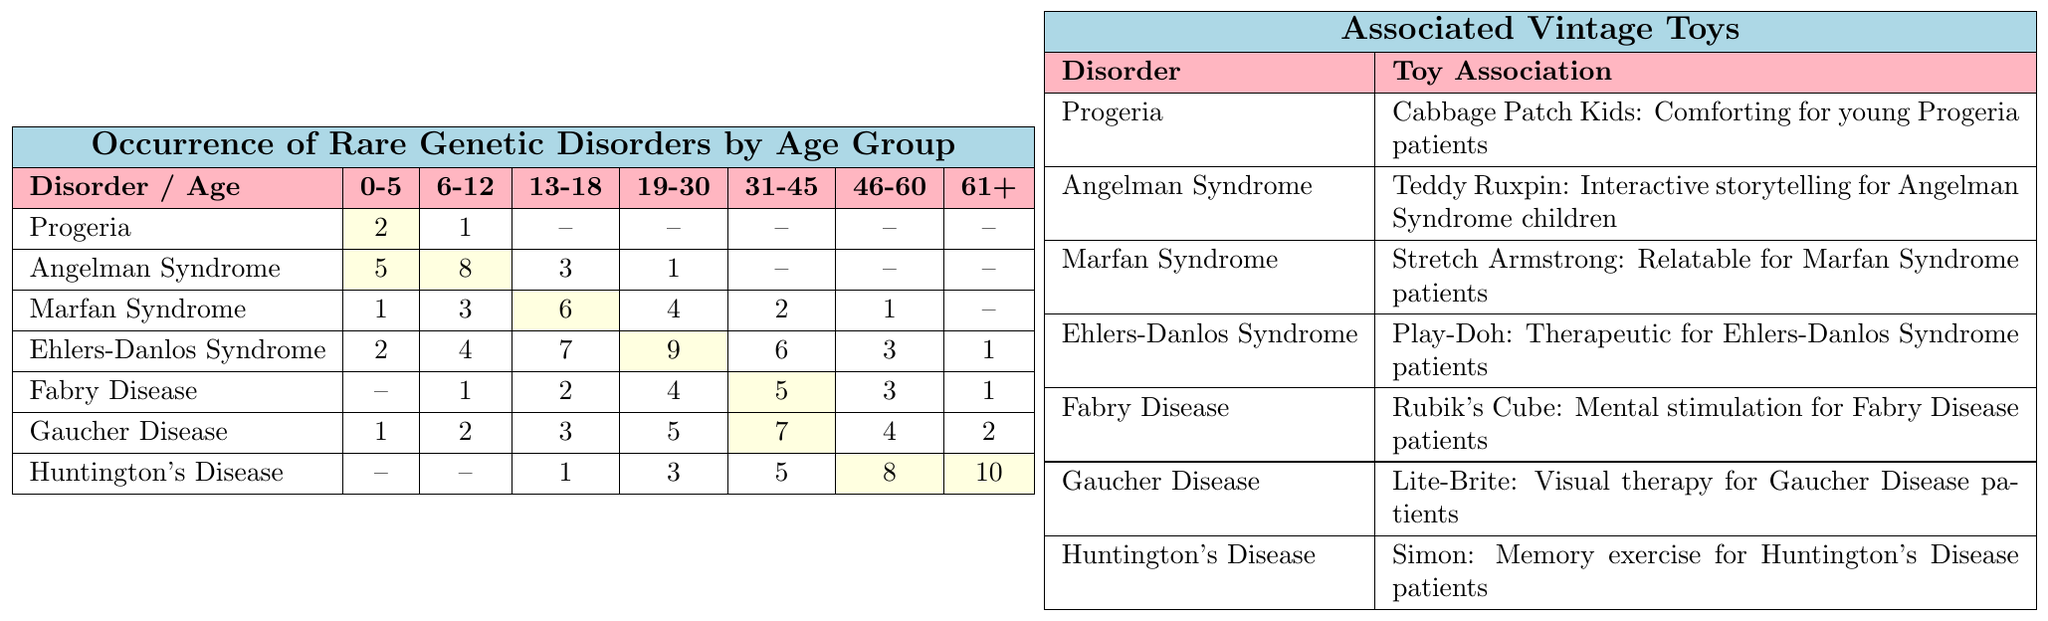What is the occurrence of Progeria in the age group 0-5? According to the table, the occurrence of Progeria in the age group 0-5 is 2.
Answer: 2 Which genetic disorder has the highest occurrence in the age group 19-30? Looking at the table, Ehlers-Danlos Syndrome has the highest occurrence in the age group 19-30 with a value of 9.
Answer: Ehlers-Danlos Syndrome What is the total occurrence of Gaucher Disease across all age groups? To find the total occurrence of Gaucher Disease, we add the values: 1 + 2 + 3 + 5 + 7 + 4 + 2 = 24.
Answer: 24 Does Angelman Syndrome occur in the age group 46-60? The table shows that the occurrence of Angelman Syndrome in the age group 46-60 is 0, which means it does not occur in that age group.
Answer: No Calculate the average occurrence of Huntington's Disease across all age groups. The occurrences for Huntington's Disease are 0, 0, 1, 3, 5, 8, 10. Adding these gives 27, and dividing by the number of age groups (7) gives an average of 27/7 ≈ 3.86.
Answer: Approximately 3.86 Which disorder has a toy association with "visual therapy"? Referring to the toy associations section, Gaucher Disease is associated with Lite-Brite for visual therapy.
Answer: Gaucher Disease Compare the total occurrences of Fabry Disease and Ehlers-Danlos Syndrome in the age group 31-45. Which one has a higher occurrence? The occurrence of Fabry Disease in the age group 31-45 is 5, and the occurrence of Ehlers-Danlos Syndrome is 6. Since 6 > 5, Ehlers-Danlos Syndrome has a higher occurrence.
Answer: Ehlers-Danlos Syndrome Does the occurrence of Marfan Syndrome increase with age after the age group 13-18? Looking at the table, the occurrences for Marfan Syndrome are 6 (13-18), 4 (19-30), 2 (31-45), 1 (46-60), showing a decrease after age 13-18.
Answer: No What is the total occurrence of rare genetic disorders for the age group 61+? To find the total for the age group 61+, we sum the occurrences: 0 (Progeria) + 0 (Angelman Syndrome) + 0 (Marfan Syndrome) + 1 + 1 + 2 + 10 = 14.
Answer: 14 Which age group has the highest total occurrence of genetic disorders? Summing the occurrences for each age group gives: 2+5+1+2+0+1+0=11 for 0-5, 1+8+3+4+1+2+0=19 for 6-12, 0+3+6+7+2+3+1=22 for 13-18, 0+1+4+9+4+5+3=26 for 19-30, 0+0+2+6+5+4+5=22 for 31-45, 0+0+1+3+7+4+8=23 for 46-60, and 0+0+0+1+1+2+10=14 for 61+. The age group 19-30 has the highest occurrence totaling 26.
Answer: 19-30 